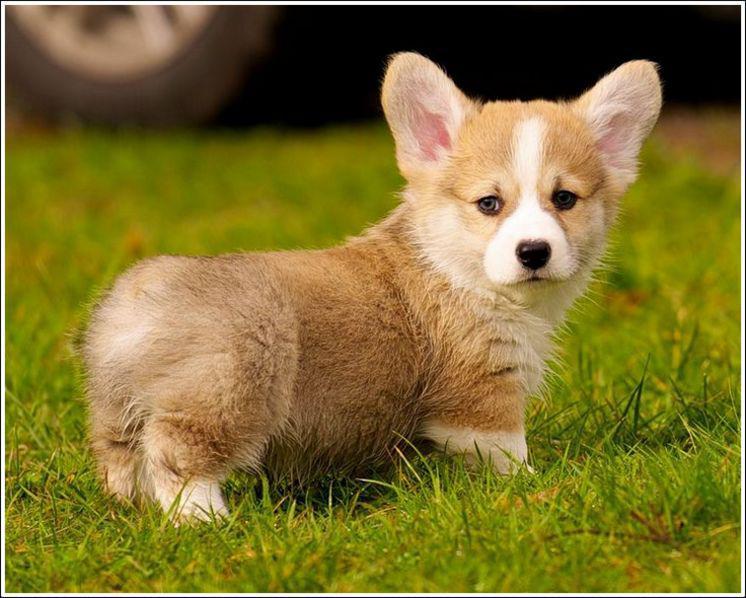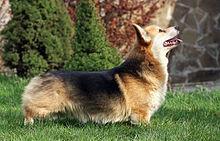The first image is the image on the left, the second image is the image on the right. Given the left and right images, does the statement "The bodies of both dogs are facing the right." hold true? Answer yes or no. Yes. The first image is the image on the left, the second image is the image on the right. For the images shown, is this caption "Each image shows exactly one short-legged dog standing in the grass." true? Answer yes or no. Yes. The first image is the image on the left, the second image is the image on the right. For the images shown, is this caption "There are at least three dogs in a grassy area." true? Answer yes or no. No. The first image is the image on the left, the second image is the image on the right. Assess this claim about the two images: "In at least one image, there is a dog sitting on the ground with at least one yellow to orange ear facing forward.". Correct or not? Answer yes or no. No. 